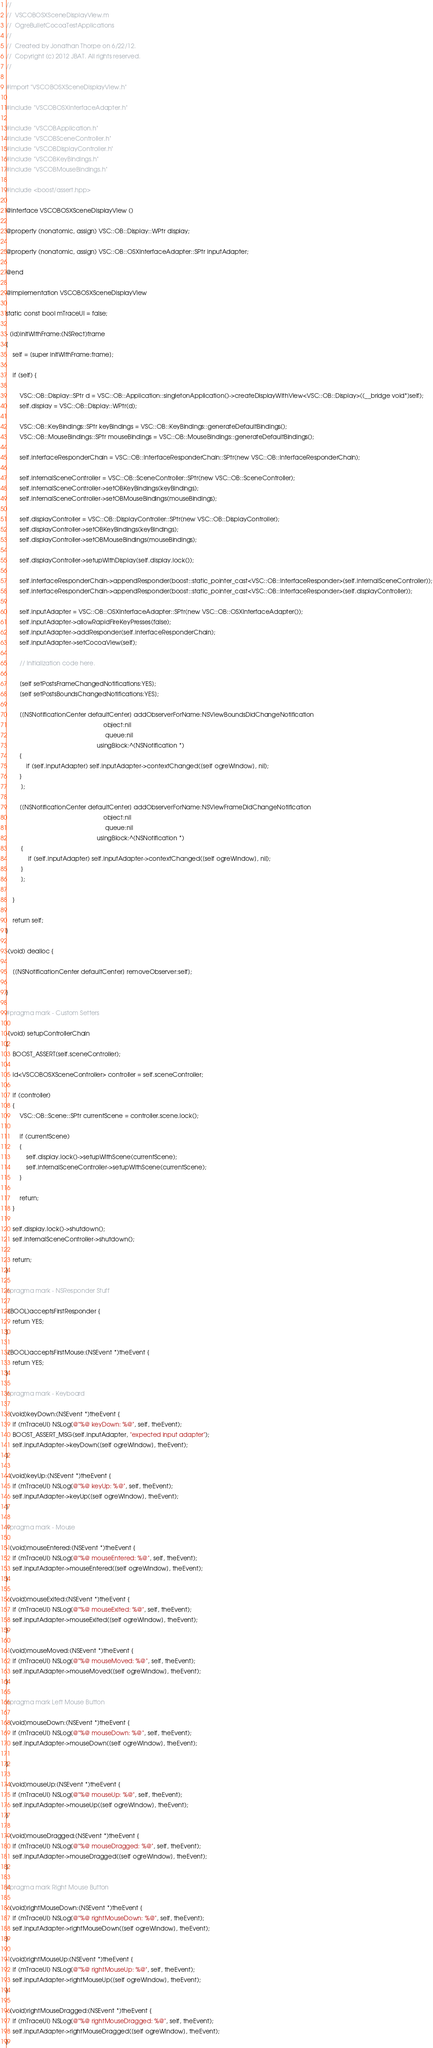Convert code to text. <code><loc_0><loc_0><loc_500><loc_500><_ObjectiveC_>//
//  VSCOBOSXSceneDisplayView.m
//  OgreBulletCocoaTestApplications
//
//  Created by Jonathan Thorpe on 6/22/12.
//  Copyright (c) 2012 JBAT. All rights reserved.
//

#import "VSCOBOSXSceneDisplayView.h"

#include "VSCOBOSXInterfaceAdapter.h"

#include "VSCOBApplication.h"
#include "VSCOBSceneController.h"
#include "VSCOBDisplayController.h"
#include "VSCOBKeyBindings.h"
#include "VSCOBMouseBindings.h"

#include <boost/assert.hpp>

@interface VSCOBOSXSceneDisplayView ()

@property (nonatomic, assign) VSC::OB::Display::WPtr display;

@property (nonatomic, assign) VSC::OB::OSXInterfaceAdapter::SPtr inputAdapter;

@end

@implementation VSCOBOSXSceneDisplayView

static const bool mTraceUI = false;

- (id)initWithFrame:(NSRect)frame
{
    self = [super initWithFrame:frame];
    
    if (self) {
        
        VSC::OB::Display::SPtr d = VSC::OB::Application::singletonApplication()->createDisplayWithView<VSC::OB::Display>((__bridge void*)self);
        self.display = VSC::OB::Display::WPtr(d);
        
        VSC::OB::KeyBindings::SPtr keyBindings = VSC::OB::KeyBindings::generateDefaultBindings();
        VSC::OB::MouseBindings::SPtr mouseBindings = VSC::OB::MouseBindings::generateDefaultBindings();
        
        self.interfaceResponderChain = VSC::OB::InterfaceResponderChain::SPtr(new VSC::OB::InterfaceResponderChain);
        
        self.internalSceneController = VSC::OB::SceneController::SPtr(new VSC::OB::SceneController);
        self.internalSceneController->setOBKeyBindings(keyBindings);
        self.internalSceneController->setOBMouseBindings(mouseBindings);
        
        self.displayController = VSC::OB::DisplayController::SPtr(new VSC::OB::DisplayController);
        self.displayController->setOBKeyBindings(keyBindings);
        self.displayController->setOBMouseBindings(mouseBindings);
        
        self.displayController->setupWithDisplay(self.display.lock());
        
        self.interfaceResponderChain->appendResponder(boost::static_pointer_cast<VSC::OB::InterfaceResponder>(self.internalSceneController));
        self.interfaceResponderChain->appendResponder(boost::static_pointer_cast<VSC::OB::InterfaceResponder>(self.displayController));
        
        self.inputAdapter = VSC::OB::OSXInterfaceAdapter::SPtr(new VSC::OB::OSXInterfaceAdapter());
        self.inputAdapter->allowRapidFireKeyPresses(false);
        self.inputAdapter->addResponder(self.interfaceResponderChain);
        self.inputAdapter->setCocoaView(self);
        
        // Initialization code here.
        
        [self setPostsFrameChangedNotifications:YES];
        [self setPostsBoundsChangedNotifications:YES];
        
        [[NSNotificationCenter defaultCenter] addObserverForName:NSViewBoundsDidChangeNotification
                                                          object:nil
                                                           queue:nil
                                                      usingBlock:^(NSNotification *)
        {
            if (self.inputAdapter) self.inputAdapter->contextChanged([self ogreWindow], nil);
        }
         ];
        
        [[NSNotificationCenter defaultCenter] addObserverForName:NSViewFrameDidChangeNotification
                                                          object:nil
                                                           queue:nil
                                                      usingBlock:^(NSNotification *)
         {
             if (self.inputAdapter) self.inputAdapter->contextChanged([self ogreWindow], nil);
         }
         ];
        
    }
    
    return self;
}

-(void) dealloc {
    
    [[NSNotificationCenter defaultCenter] removeObserver:self];
    
}

#pragma mark - Custom Setters

-(void) setupControllerChain
{
    BOOST_ASSERT(self.sceneController);
    
    id<VSCOBOSXSceneController> controller = self.sceneController;
    
    if (controller)
    {
        VSC::OB::Scene::SPtr currentScene = controller.scene.lock();
            
        if (currentScene)
        {
            self.display.lock()->setupWithScene(currentScene);
            self.internalSceneController->setupWithScene(currentScene);
        }
        
        return;
    }

    self.display.lock()->shutdown();
    self.internalSceneController->shutdown();

    return;
}

#pragma mark - NSResponder Stuff

-(BOOL)acceptsFirstResponder {
    return YES;
}

-(BOOL)acceptsFirstMouse:(NSEvent *)theEvent {
    return YES;
}

#pragma mark - Keyboard

- (void)keyDown:(NSEvent *)theEvent {
    if (mTraceUI) NSLog(@"%@ keyDown: %@", self, theEvent);
    BOOST_ASSERT_MSG(self.inputAdapter, "expected input adapter");
    self.inputAdapter->keyDown([self ogreWindow], theEvent);
}

- (void)keyUp:(NSEvent *)theEvent {
    if (mTraceUI) NSLog(@"%@ keyUp: %@", self, theEvent);
    self.inputAdapter->keyUp([self ogreWindow], theEvent); 
}

#pragma mark - Mouse

- (void)mouseEntered:(NSEvent *)theEvent {
    if (mTraceUI) NSLog(@"%@ mouseEntered: %@", self, theEvent);
    self.inputAdapter->mouseEntered([self ogreWindow], theEvent); 
}

- (void)mouseExited:(NSEvent *)theEvent {
    if (mTraceUI) NSLog(@"%@ mouseExited: %@", self, theEvent);
    self.inputAdapter->mouseExited([self ogreWindow], theEvent); 
}

- (void)mouseMoved:(NSEvent *)theEvent {
    if (mTraceUI) NSLog(@"%@ mouseMoved: %@", self, theEvent);
    self.inputAdapter->mouseMoved([self ogreWindow], theEvent); 
}

#pragma mark Left Mouse Button

- (void)mouseDown:(NSEvent *)theEvent {
    if (mTraceUI) NSLog(@"%@ mouseDown: %@", self, theEvent);
    self.inputAdapter->mouseDown([self ogreWindow], theEvent);
    
}

- (void)mouseUp:(NSEvent *)theEvent {
    if (mTraceUI) NSLog(@"%@ mouseUp: %@", self, theEvent);
    self.inputAdapter->mouseUp([self ogreWindow], theEvent);
}

- (void)mouseDragged:(NSEvent *)theEvent {
    if (mTraceUI) NSLog(@"%@ mouseDragged: %@", self, theEvent);
    self.inputAdapter->mouseDragged([self ogreWindow], theEvent);
}

#pragma mark Right Mouse Button

- (void)rightMouseDown:(NSEvent *)theEvent {
    if (mTraceUI) NSLog(@"%@ rightMouseDown: %@", self, theEvent);
    self.inputAdapter->rightMouseDown([self ogreWindow], theEvent);
}

- (void)rightMouseUp:(NSEvent *)theEvent {
    if (mTraceUI) NSLog(@"%@ rightMouseUp: %@", self, theEvent);
    self.inputAdapter->rightMouseUp([self ogreWindow], theEvent);
}

- (void)rightMouseDragged:(NSEvent *)theEvent {
    if (mTraceUI) NSLog(@"%@ rightMouseDragged: %@", self, theEvent);
    self.inputAdapter->rightMouseDragged([self ogreWindow], theEvent);
}
</code> 